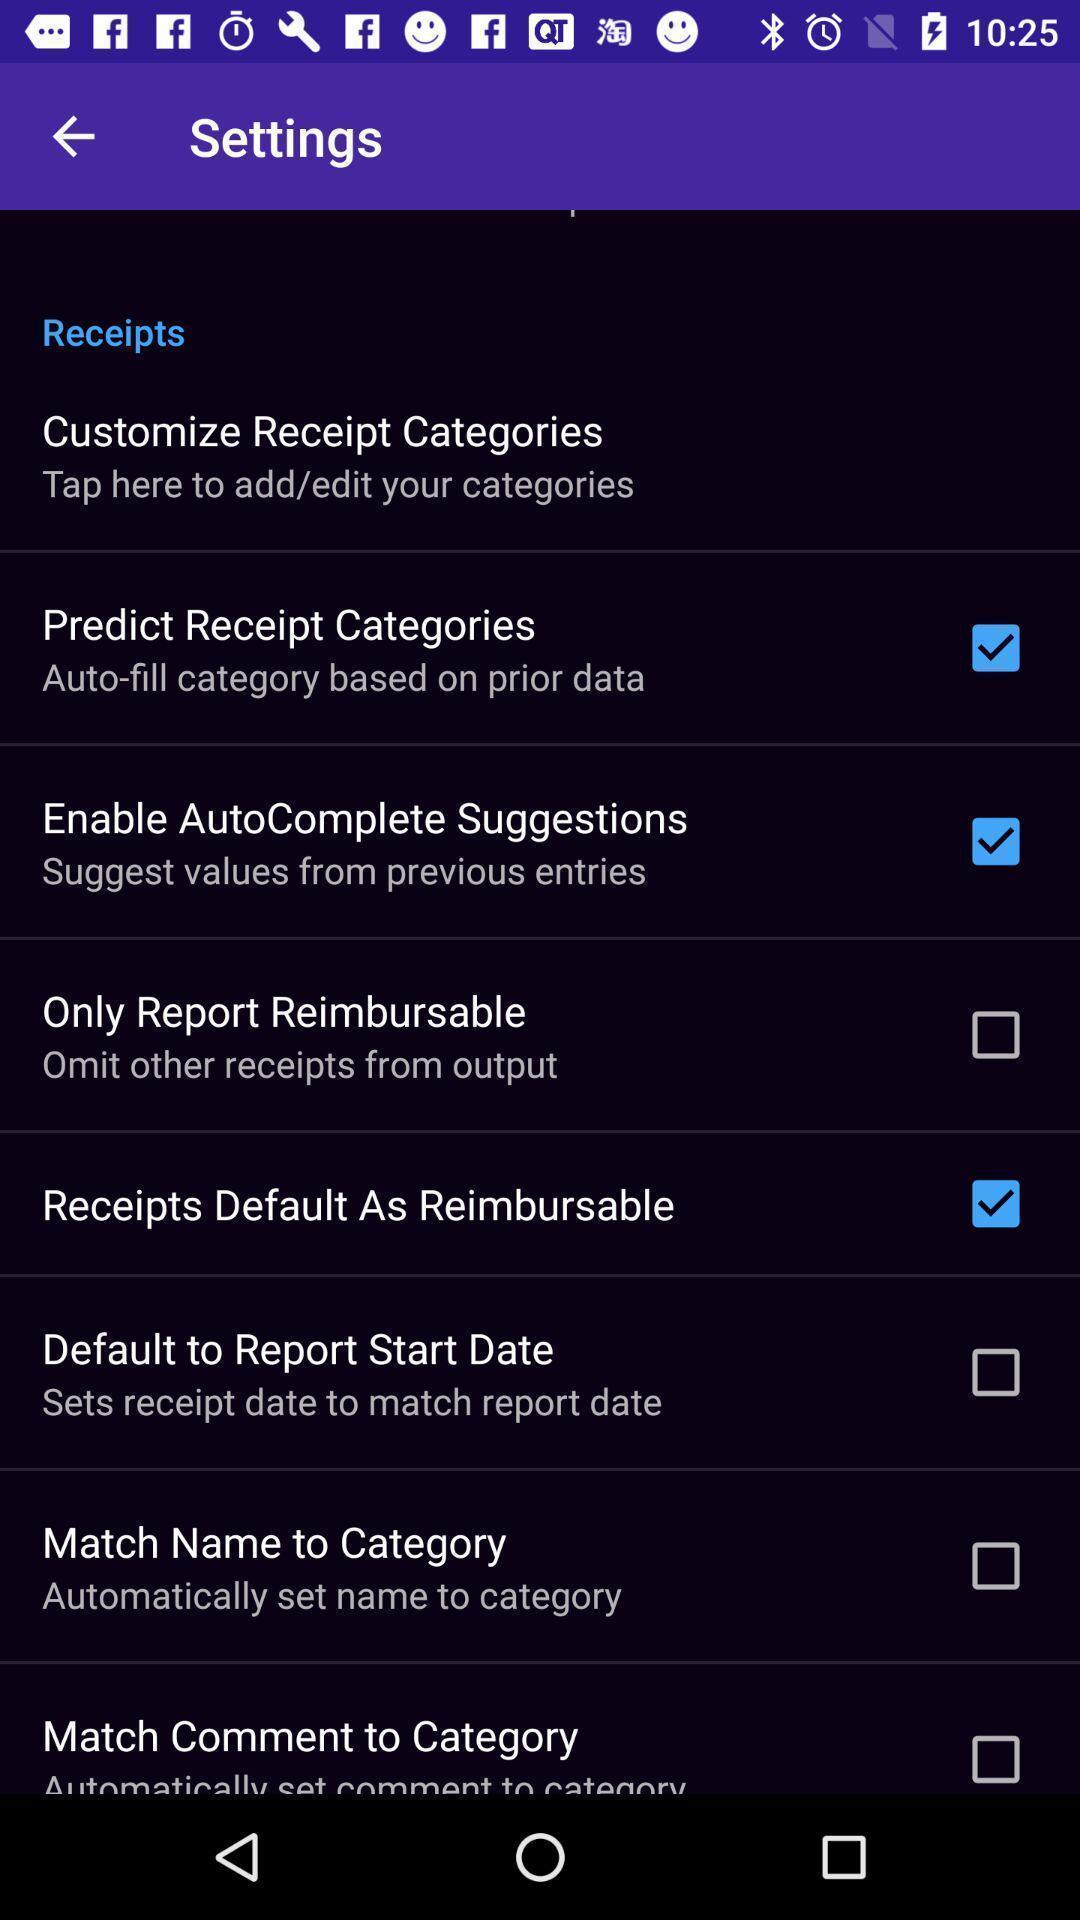Provide a detailed account of this screenshot. Screen shows receipts in settings. 